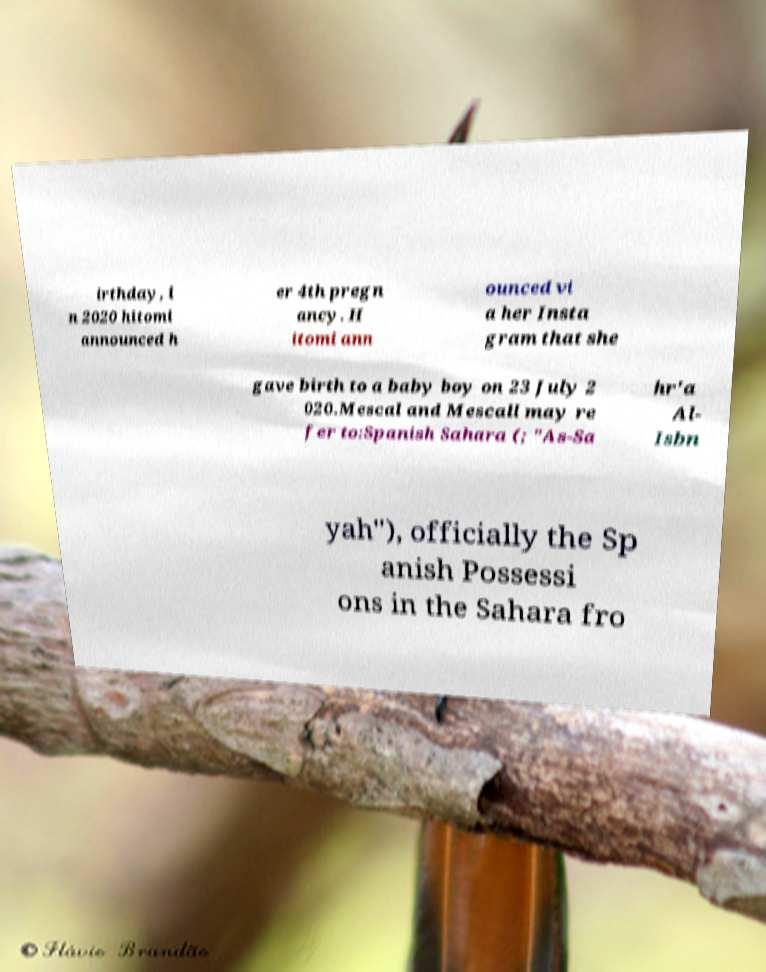Could you assist in decoding the text presented in this image and type it out clearly? irthday, i n 2020 hitomi announced h er 4th pregn ancy. H itomi ann ounced vi a her Insta gram that she gave birth to a baby boy on 23 July 2 020.Mescal and Mescall may re fer to:Spanish Sahara (; "As-Sa hr'a Al- Isbn yah"), officially the Sp anish Possessi ons in the Sahara fro 